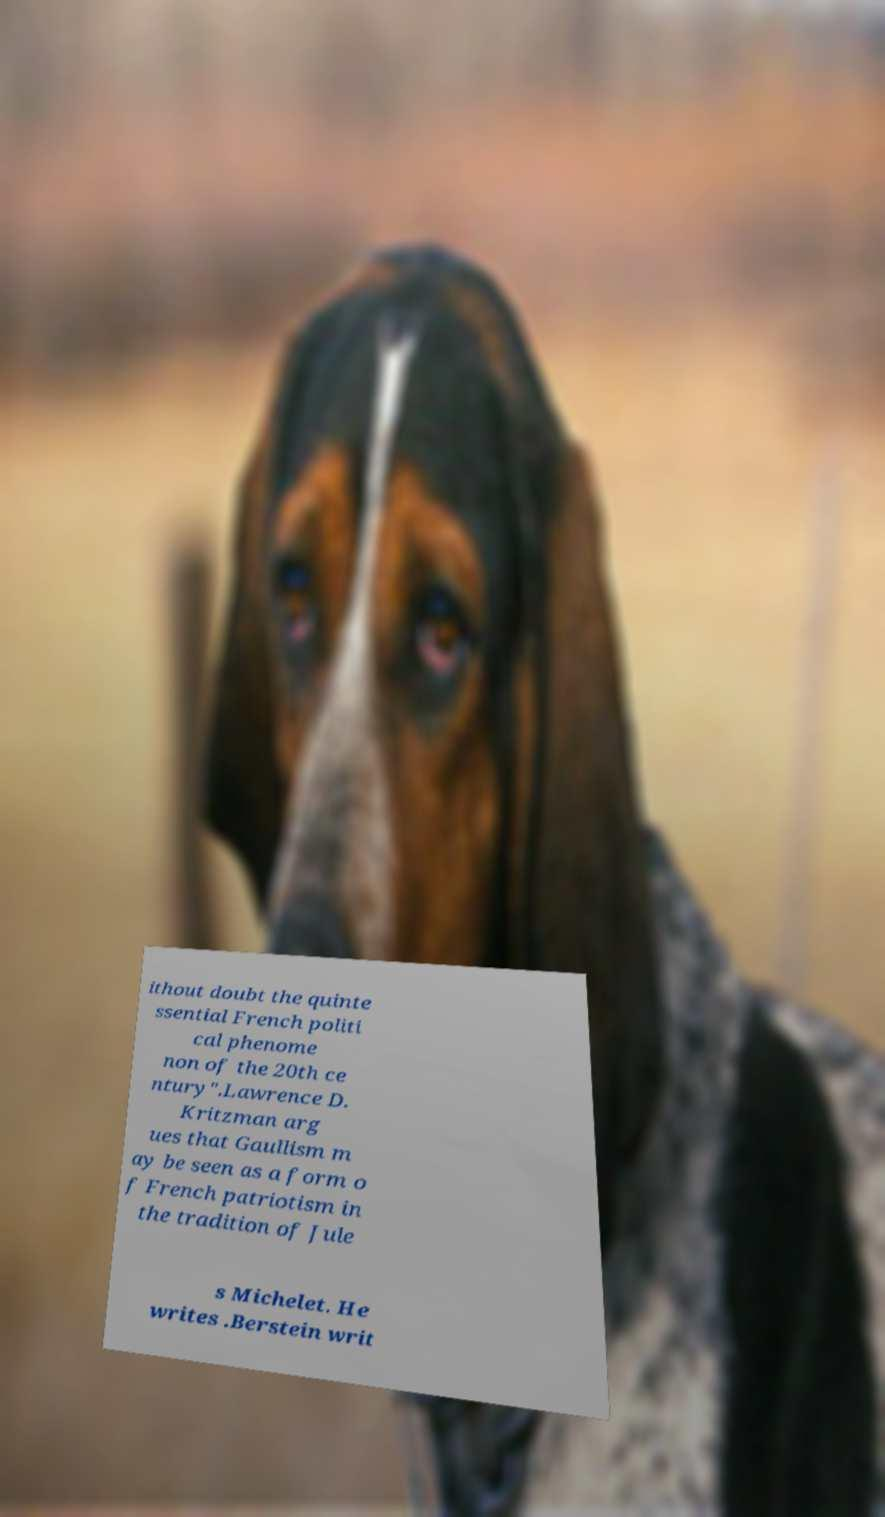Can you read and provide the text displayed in the image?This photo seems to have some interesting text. Can you extract and type it out for me? ithout doubt the quinte ssential French politi cal phenome non of the 20th ce ntury".Lawrence D. Kritzman arg ues that Gaullism m ay be seen as a form o f French patriotism in the tradition of Jule s Michelet. He writes .Berstein writ 